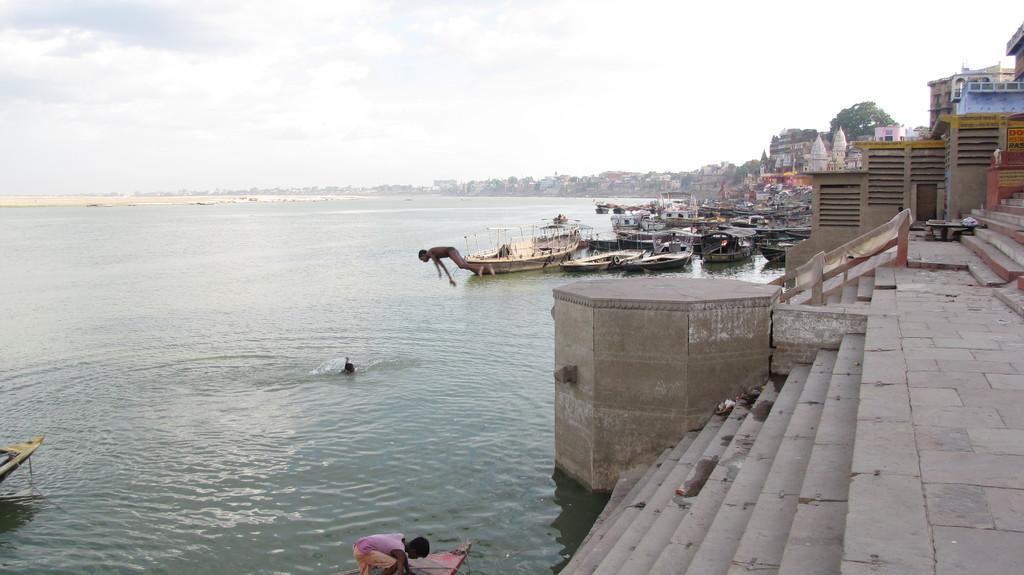Could you give a brief overview of what you see in this image? This is an outside view. On the right side there are stairs, many buildings and trees. In the middle of the image there are many boats on the water and one person is jumping into the water. At the bottom there is a person. At the top of the image I can see the sky and clouds. 